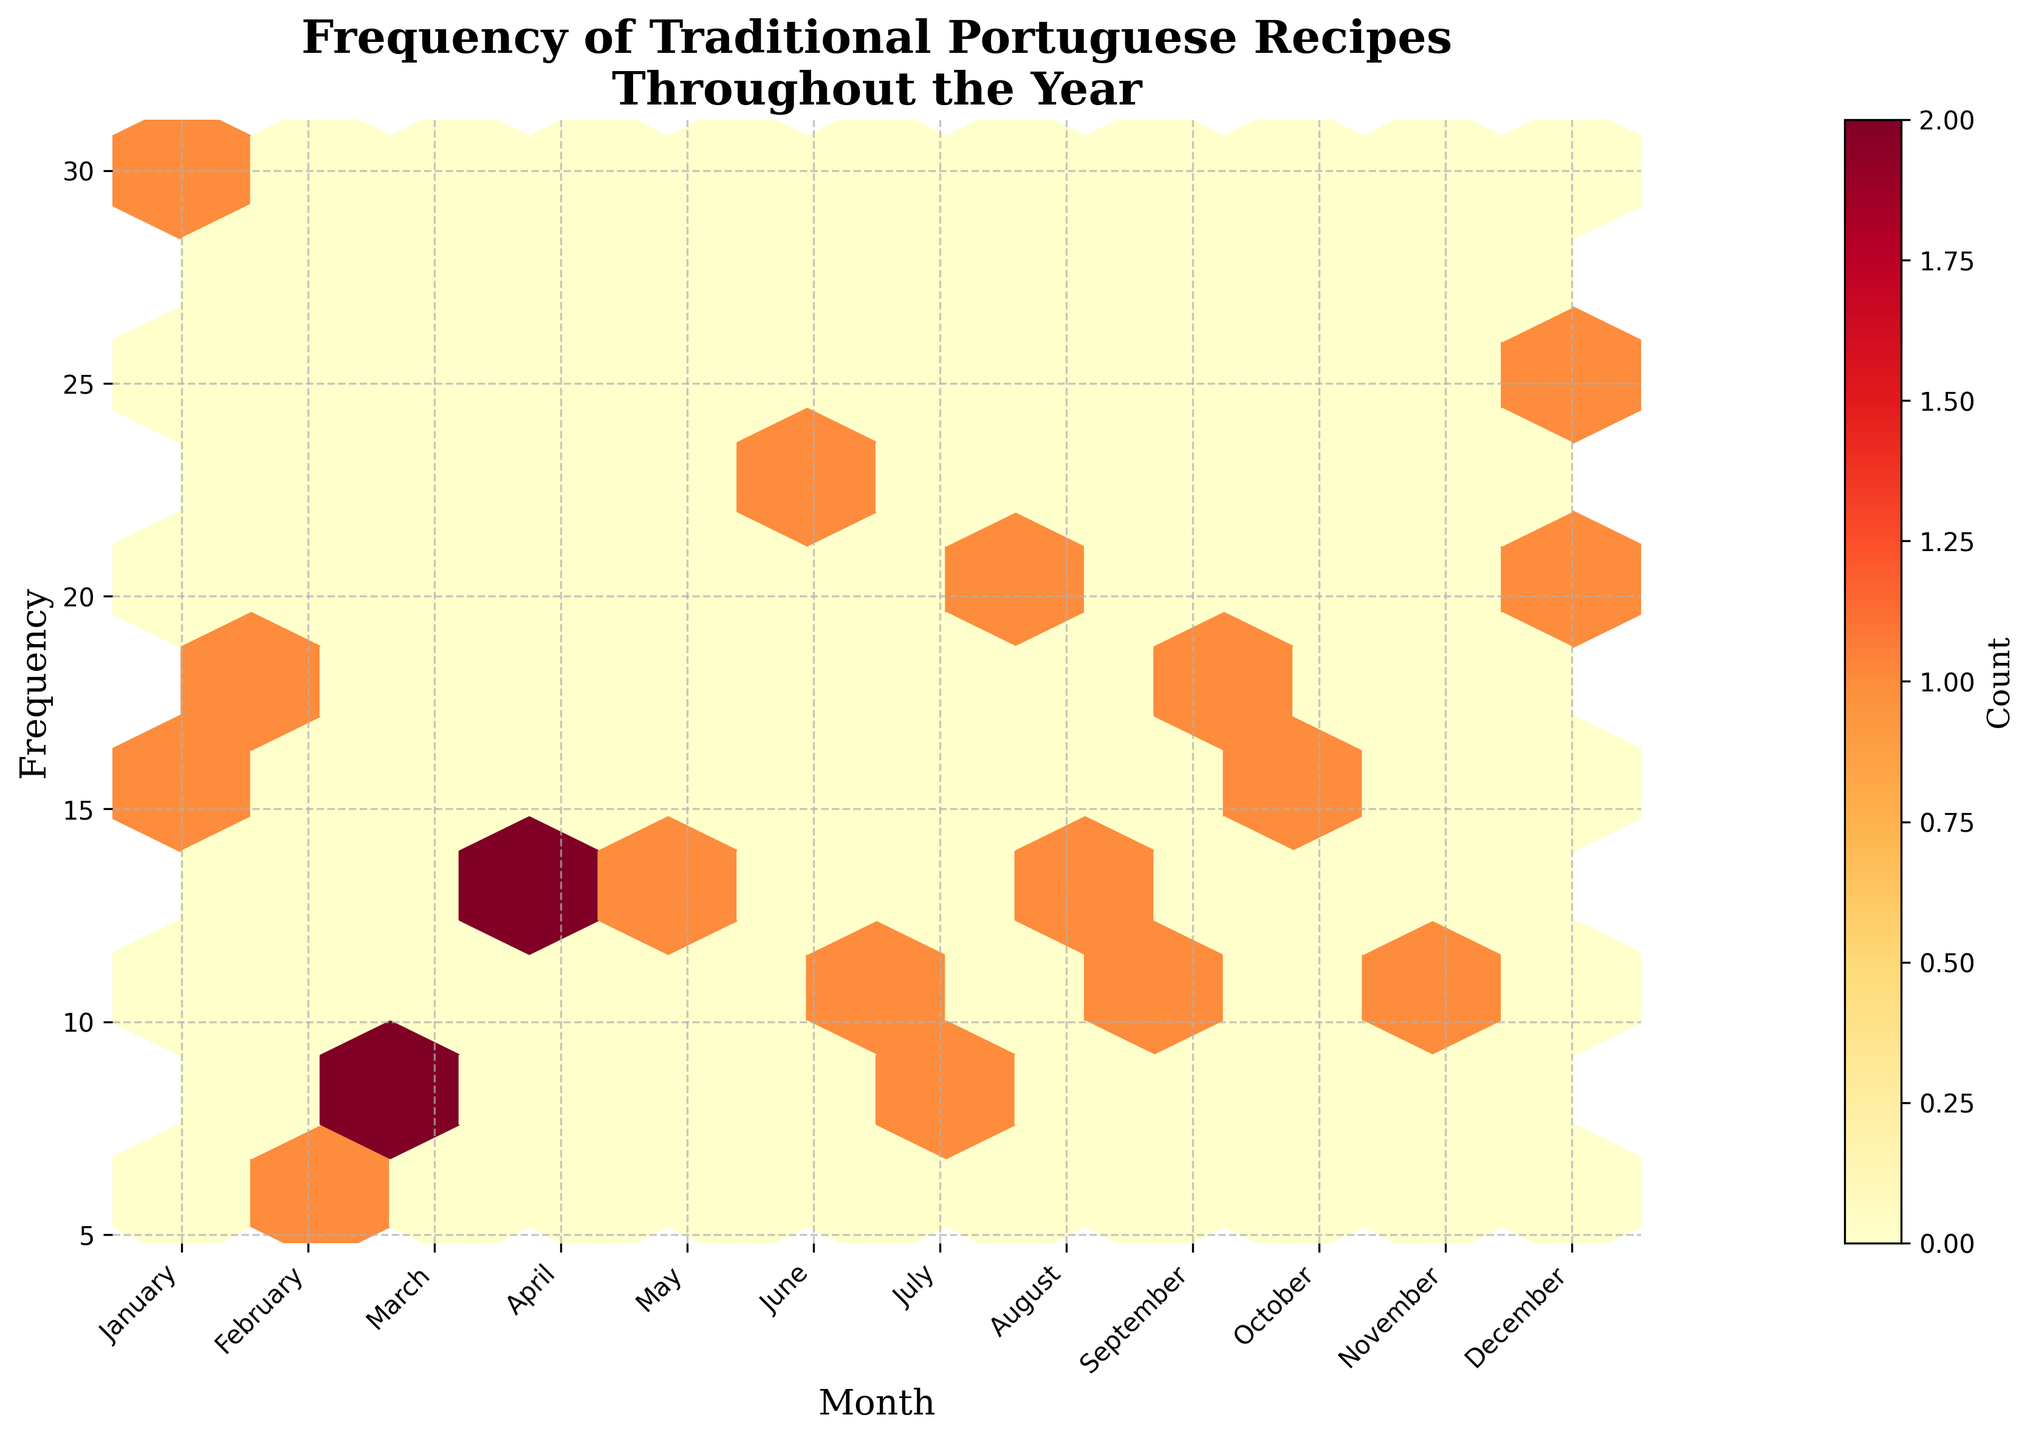What is the title of the figure? The title is typically shown at the top of the figure and it provides the main subject of the plot.
Answer: Frequency of Traditional Portuguese Recipes Throughout the Year Which month has the highest frequency of recipes being cooked? Look for the hexbin with the most concentration at the highest frequency values on the x-axis and read the corresponding month from the x-axis labels.
Answer: December Which month has the lowest frequency of recipes being cooked? Look for the hexbin with the least concentration at the lowest frequency values on the x-axis and read the corresponding month from the x-axis labels.
Answer: March What is the color of the hexbin area where the frequency is highest? The color indicates density, so identify the darkest or most intense color patch in the hexbin plot.
Answer: Dark red How does the frequency of recipes cooked in January compare to the frequency in August? Identify the hexbin concentrations near January and August on the x-axis and compare their densities in terms of color intensity.
Answer: Higher in January In which months are traditional Portuguese recipes cooked at a frequency between 10 and 20 times? Look for hexbin concentrations that fall between 10 and 20 on the frequency y-axis and check the corresponding months on the x-axis.
Answer: January, April, August, September, October, November How many months show a high concentration of recipes being cooked at least 15 times? Count the number of months where the hexbin colors indicate a high density (typically warmer colors like orange and red) above the 15 frequency mark.
Answer: Four months In which month do the recipes have the broadest range of frequencies? Look for the month that shows the largest spread of hexbin colors along the frequency y-axis.
Answer: January What is the month shown at the farthest left of the x-axis? The x-axis represents months in order, so the month at the left-most end is the one with the lowest index.
Answer: January How does the frequency variation in December compare to that in February? Compare the spread and intensity of hexbins in December with those in February to analyze the variation in frequencies.
Answer: More variation in December 